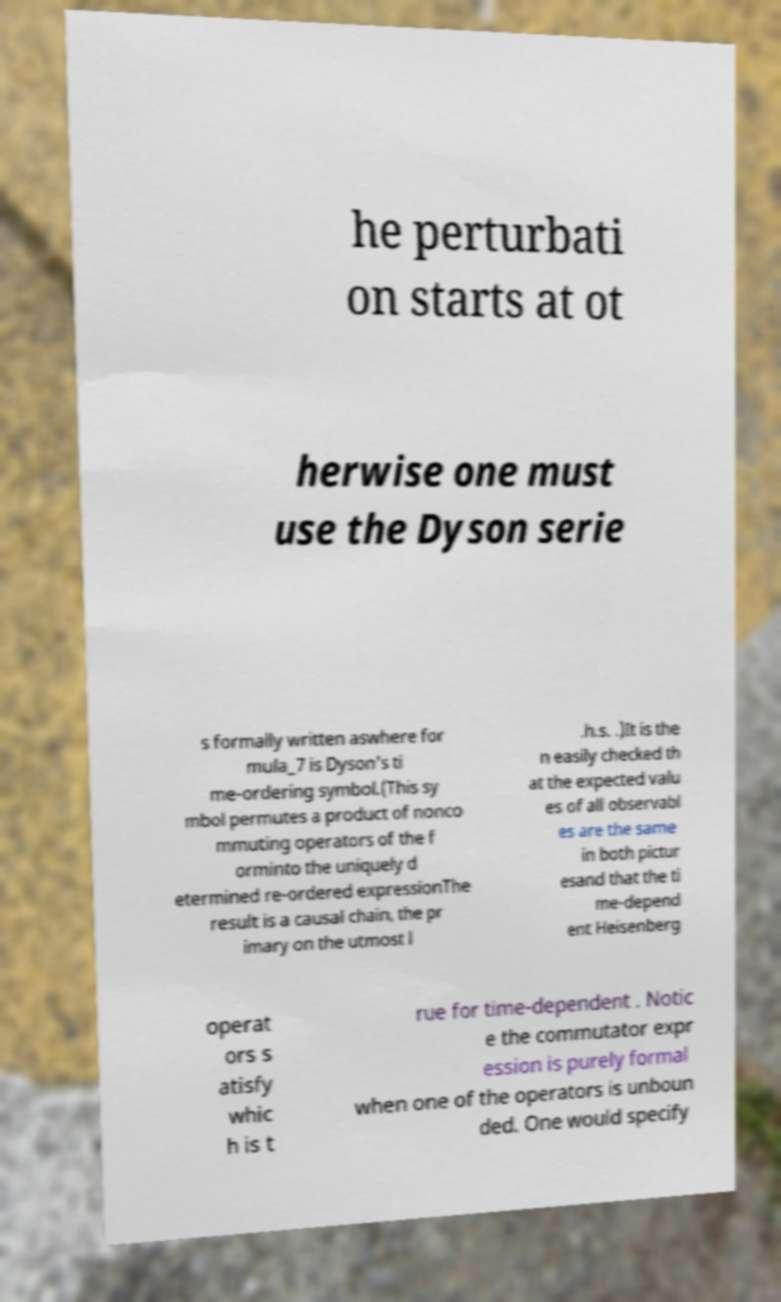What messages or text are displayed in this image? I need them in a readable, typed format. he perturbati on starts at ot herwise one must use the Dyson serie s formally written aswhere for mula_7 is Dyson's ti me-ordering symbol.(This sy mbol permutes a product of nonco mmuting operators of the f orminto the uniquely d etermined re-ordered expressionThe result is a causal chain, the pr imary on the utmost l .h.s. .)It is the n easily checked th at the expected valu es of all observabl es are the same in both pictur esand that the ti me-depend ent Heisenberg operat ors s atisfy whic h is t rue for time-dependent . Notic e the commutator expr ession is purely formal when one of the operators is unboun ded. One would specify 